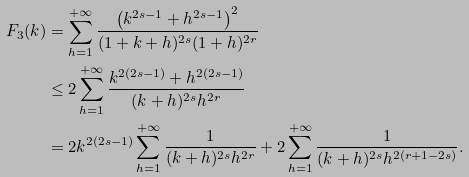Convert formula to latex. <formula><loc_0><loc_0><loc_500><loc_500>F _ { 3 } ( k ) & = \sum _ { h = 1 } ^ { + \infty } \frac { \left ( k ^ { 2 s - 1 } + h ^ { 2 s - 1 } \right ) ^ { 2 } } { ( 1 + k + h ) ^ { 2 s } ( 1 + h ) ^ { 2 r } } \\ & \leq 2 \sum _ { h = 1 } ^ { + \infty } \frac { k ^ { 2 ( 2 s - 1 ) } + h ^ { 2 ( 2 s - 1 ) } } { ( k + h ) ^ { 2 s } h ^ { 2 r } } \\ & = 2 k ^ { 2 ( 2 s - 1 ) } \sum _ { h = 1 } ^ { + \infty } \frac { 1 } { ( k + h ) ^ { 2 s } h ^ { 2 r } } + 2 \sum _ { h = 1 } ^ { + \infty } \frac { 1 } { ( k + h ) ^ { 2 s } h ^ { 2 ( r + 1 - 2 s ) } } .</formula> 